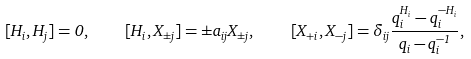Convert formula to latex. <formula><loc_0><loc_0><loc_500><loc_500>[ H _ { i } , H _ { j } ] = 0 , \quad [ H _ { i } , X _ { \pm j } ] = \pm a _ { i j } X _ { \pm j } , \quad [ X _ { + i } , X _ { - j } ] = \delta _ { i j } \frac { q _ { i } ^ { H _ { i } } - q _ { i } ^ { - H _ { i } } } { q _ { i } - q _ { i } ^ { - 1 } } , \\</formula> 